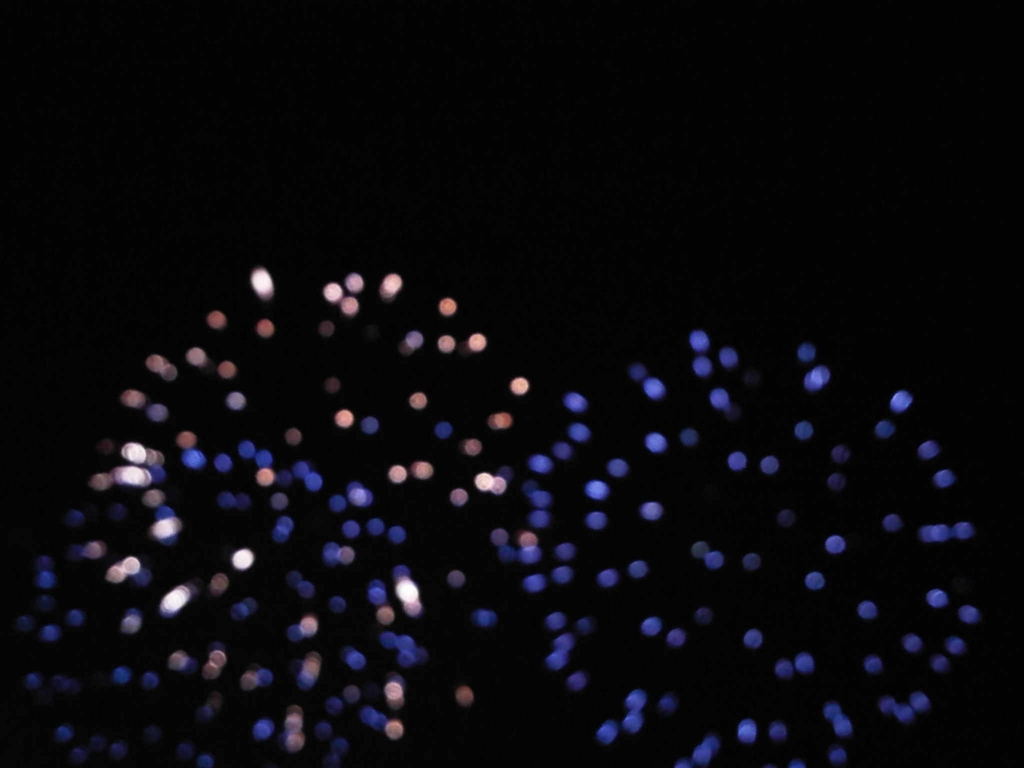How might one improve the quality of a similar image? To enhance image quality one could ensure proper focus to avoid blurriness, adjust the aperture setting to control the depth of field, and use a stable surface or tripod to reduce camera shake. Additionally, composing the shot with a clear subject or point of interest could make the image more engaging. 